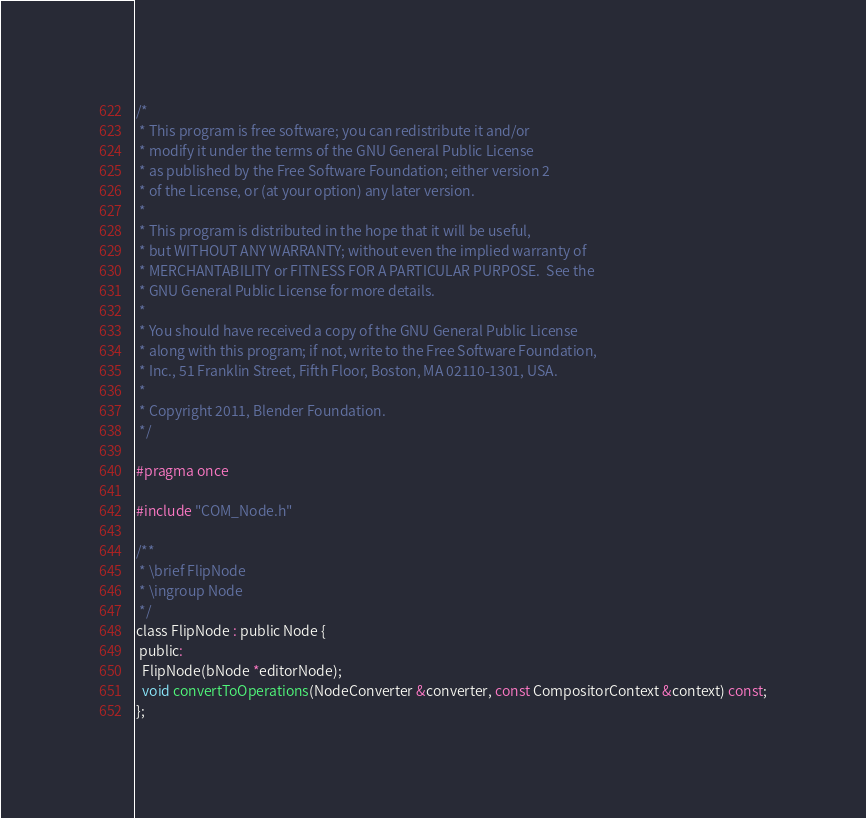Convert code to text. <code><loc_0><loc_0><loc_500><loc_500><_C_>/*
 * This program is free software; you can redistribute it and/or
 * modify it under the terms of the GNU General Public License
 * as published by the Free Software Foundation; either version 2
 * of the License, or (at your option) any later version.
 *
 * This program is distributed in the hope that it will be useful,
 * but WITHOUT ANY WARRANTY; without even the implied warranty of
 * MERCHANTABILITY or FITNESS FOR A PARTICULAR PURPOSE.  See the
 * GNU General Public License for more details.
 *
 * You should have received a copy of the GNU General Public License
 * along with this program; if not, write to the Free Software Foundation,
 * Inc., 51 Franklin Street, Fifth Floor, Boston, MA 02110-1301, USA.
 *
 * Copyright 2011, Blender Foundation.
 */

#pragma once

#include "COM_Node.h"

/**
 * \brief FlipNode
 * \ingroup Node
 */
class FlipNode : public Node {
 public:
  FlipNode(bNode *editorNode);
  void convertToOperations(NodeConverter &converter, const CompositorContext &context) const;
};
</code> 